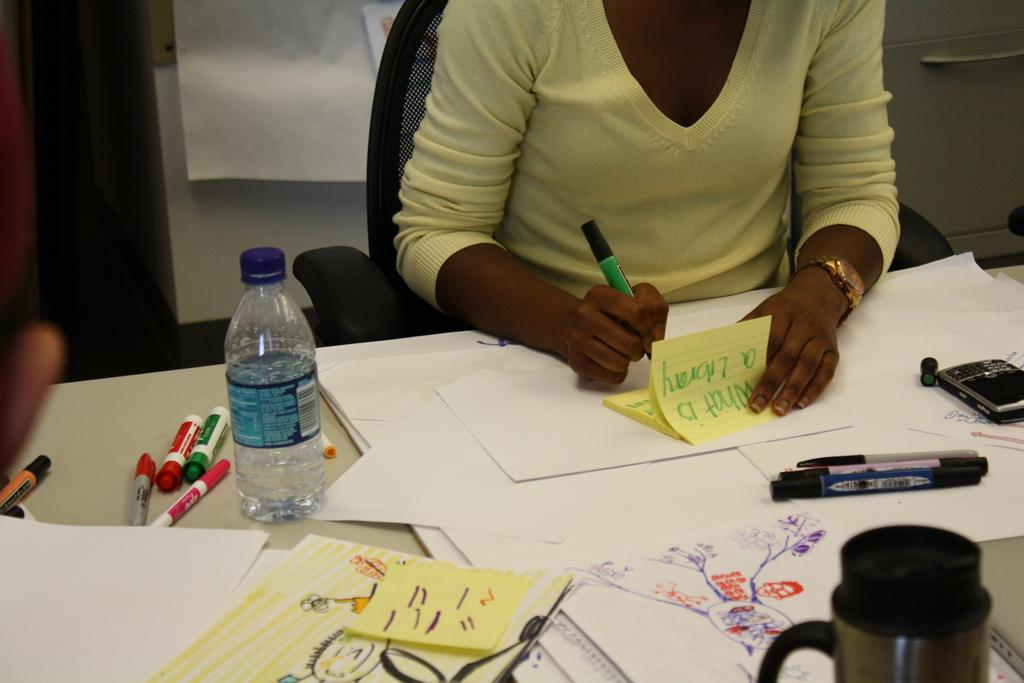What is the person in the image doing? The person is sitting on a chair and holding a pen. What is on the table in front of the person? There is a bottle, a paper, pens, and a flask on the table. What might the person be using the pen for? The person might be using the pen to write or draw on the paper. How many pens are visible on the table? There are pens on the table. What is the person's memory like in the image? The image does not provide any information about the person's memory. Can you describe the person's sense of touch in the image? The image does not provide any information about the person's sense of touch. 